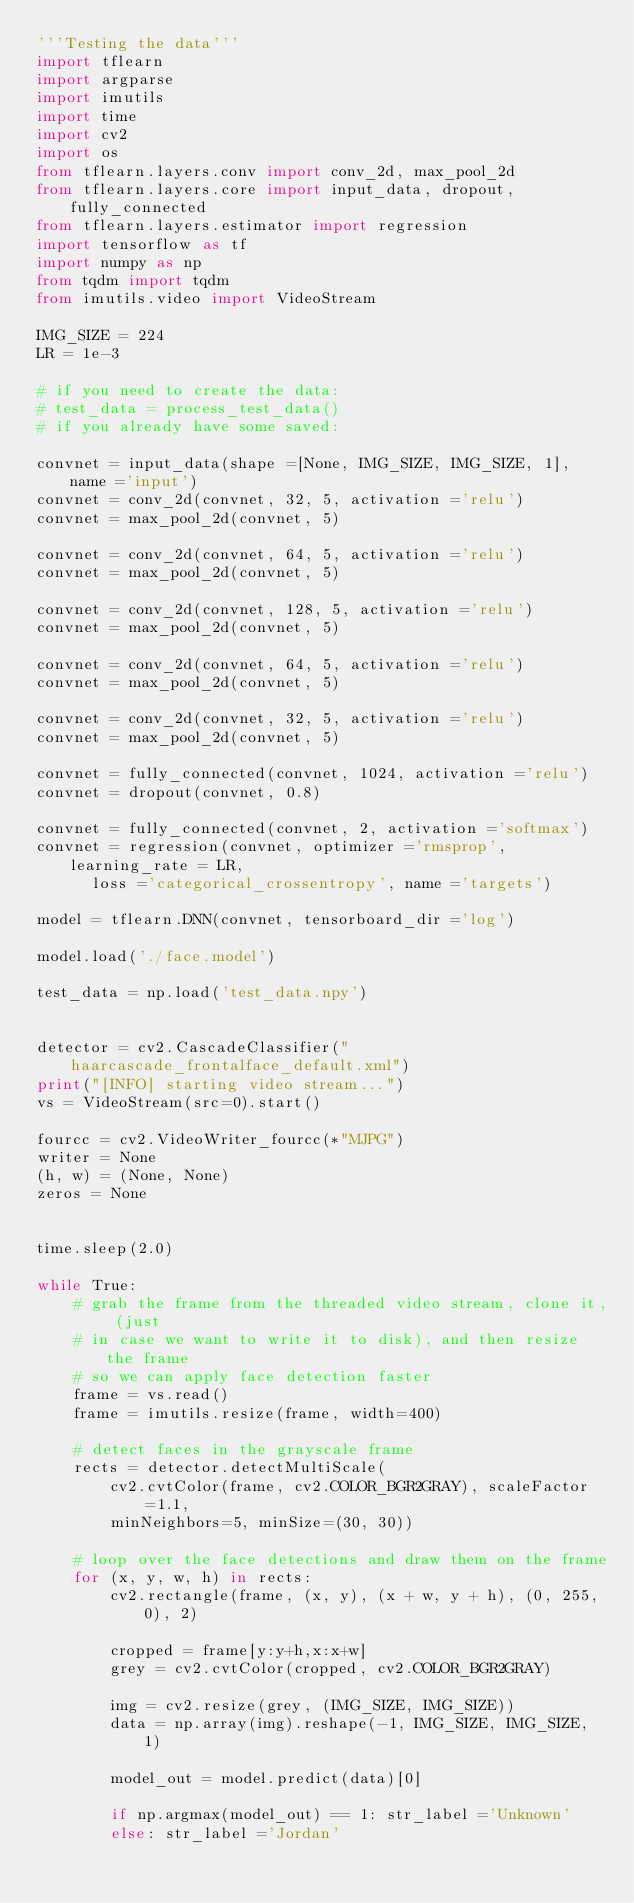<code> <loc_0><loc_0><loc_500><loc_500><_Python_>'''Testing the data''' 
import tflearn 
import argparse
import imutils
import time
import cv2
import os
from tflearn.layers.conv import conv_2d, max_pool_2d 
from tflearn.layers.core import input_data, dropout, fully_connected 
from tflearn.layers.estimator import regression   
import tensorflow as tf 
import numpy as np 
from tqdm import tqdm 
from imutils.video import VideoStream

IMG_SIZE = 224
LR = 1e-3

# if you need to create the data: 
# test_data = process_test_data() 
# if you already have some saved:

convnet = input_data(shape =[None, IMG_SIZE, IMG_SIZE, 1], name ='input')   
convnet = conv_2d(convnet, 32, 5, activation ='relu') 
convnet = max_pool_2d(convnet, 5) 
  
convnet = conv_2d(convnet, 64, 5, activation ='relu') 
convnet = max_pool_2d(convnet, 5) 
  
convnet = conv_2d(convnet, 128, 5, activation ='relu') 
convnet = max_pool_2d(convnet, 5) 
  
convnet = conv_2d(convnet, 64, 5, activation ='relu') 
convnet = max_pool_2d(convnet, 5) 
  
convnet = conv_2d(convnet, 32, 5, activation ='relu') 
convnet = max_pool_2d(convnet, 5) 
  
convnet = fully_connected(convnet, 1024, activation ='relu') 
convnet = dropout(convnet, 0.8) 
  
convnet = fully_connected(convnet, 2, activation ='softmax') 
convnet = regression(convnet, optimizer ='rmsprop', learning_rate = LR, 
      loss ='categorical_crossentropy', name ='targets') 
  
model = tflearn.DNN(convnet, tensorboard_dir ='log') 

model.load('./face.model')

test_data = np.load('test_data.npy') 
  

detector = cv2.CascadeClassifier("haarcascade_frontalface_default.xml")
print("[INFO] starting video stream...")
vs = VideoStream(src=0).start()

fourcc = cv2.VideoWriter_fourcc(*"MJPG")
writer = None
(h, w) = (None, None)
zeros = None


time.sleep(2.0)

while True:
    # grab the frame from the threaded video stream, clone it, (just
    # in case we want to write it to disk), and then resize the frame
    # so we can apply face detection faster
    frame = vs.read()
    frame = imutils.resize(frame, width=400)
 
    # detect faces in the grayscale frame
    rects = detector.detectMultiScale(
        cv2.cvtColor(frame, cv2.COLOR_BGR2GRAY), scaleFactor=1.1, 
        minNeighbors=5, minSize=(30, 30))
 
    # loop over the face detections and draw them on the frame
    for (x, y, w, h) in rects:
        cv2.rectangle(frame, (x, y), (x + w, y + h), (0, 255, 0), 2)

        cropped = frame[y:y+h,x:x+w]
        grey = cv2.cvtColor(cropped, cv2.COLOR_BGR2GRAY)

        img = cv2.resize(grey, (IMG_SIZE, IMG_SIZE)) 
        data = np.array(img).reshape(-1, IMG_SIZE, IMG_SIZE, 1) 

        model_out = model.predict(data)[0]

        if np.argmax(model_out) == 1: str_label ='Unknown'
        else: str_label ='Jordan'
</code> 